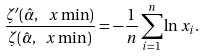<formula> <loc_0><loc_0><loc_500><loc_500>\frac { \zeta ^ { \prime } ( \hat { \alpha } , \ x \min ) } { \zeta ( \hat { \alpha } , \ x \min ) } = - \frac { 1 } { n } \sum _ { i = 1 } ^ { n } \ln x _ { i } .</formula> 